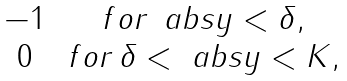<formula> <loc_0><loc_0><loc_500><loc_500>\begin{matrix} - 1 & \, f o r \, \ a b s { y } < \delta , \\ 0 & \, f o r \, \delta < \ a b s { y } < K , \end{matrix}</formula> 